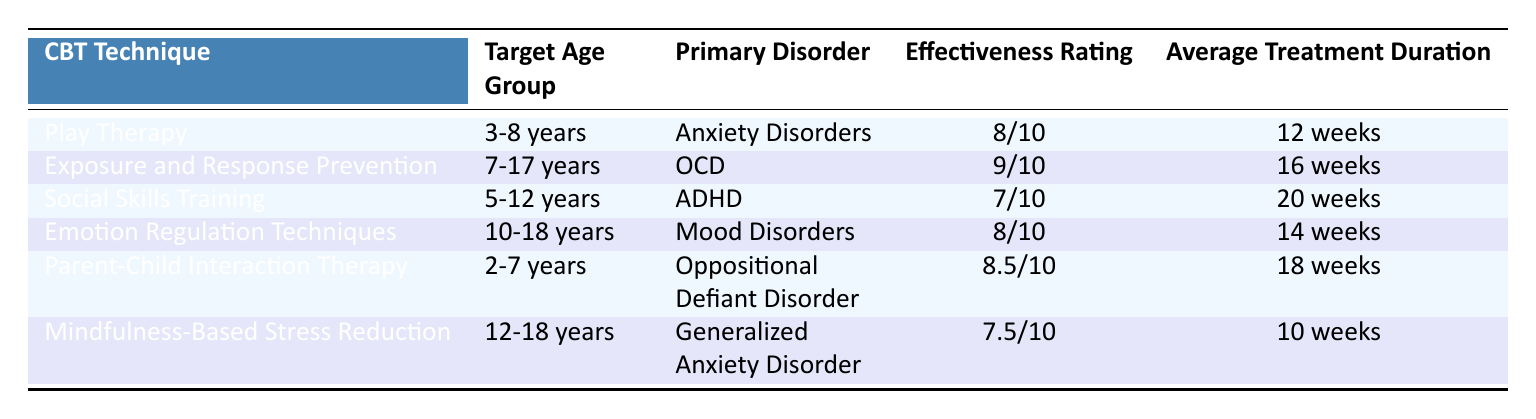What is the effectiveness rating of Play Therapy? The effectiveness rating for Play Therapy is listed in the table under the "Effectiveness Rating" column. It shows an 8/10 rating.
Answer: 8/10 Which CBT technique targets children aged 10-18 years? In the age group of 10-18 years, the technique listed is "Emotion Regulation Techniques" and "Mindfulness-Based Stress Reduction". Both techniques are applicable to this age group.
Answer: Emotion Regulation Techniques, Mindfulness-Based Stress Reduction Is Parent-Child Interaction Therapy effective for children with ADHD? According to the table, Parent-Child Interaction Therapy is used primarily for Oppositional Defiant Disorder, not ADHD. Therefore, it is not specifically effective for children with ADHD.
Answer: No What is the average treatment duration for Exposure and Response Prevention and Emotion Regulation Techniques combined? The treatment duration for Exposure and Response Prevention is 16 weeks, and for Emotion Regulation Techniques, it is 14 weeks. Adding these gives 16 + 14 = 30 weeks. Therefore, the average for these two is 30/2 = 15 weeks.
Answer: 15 weeks Does any CBT technique target children under the age of 3? The table does not list any CBT techniques targeting children under the age of 3. Since the youngest listed age is 2 years for Parent-Child Interaction Therapy, the answer is no.
Answer: No Which technique has the highest effectiveness rating? By scanning through the "Effectiveness Rating" column, the highest rating is 9/10 for "Exposure and Response Prevention" for OCD.
Answer: Exposure and Response Prevention What is the difference in effectiveness ratings between Social Skills Training and Parent-Child Interaction Therapy? Social Skills Training has an effectiveness rating of 7/10 and Parent-Child Interaction Therapy has an 8.5/10 rating. The difference is calculated by subtracting 7 from 8.5, which yields 1.5.
Answer: 1.5 Which disorder associated with CBT techniques has the longest average treatment duration? Looking at the "Average Treatment Duration" column, Social Skills Training has an average duration of 20 weeks, which is the longest compared to the other listed techniques.
Answer: ADHD (Social Skills Training, 20 weeks) 